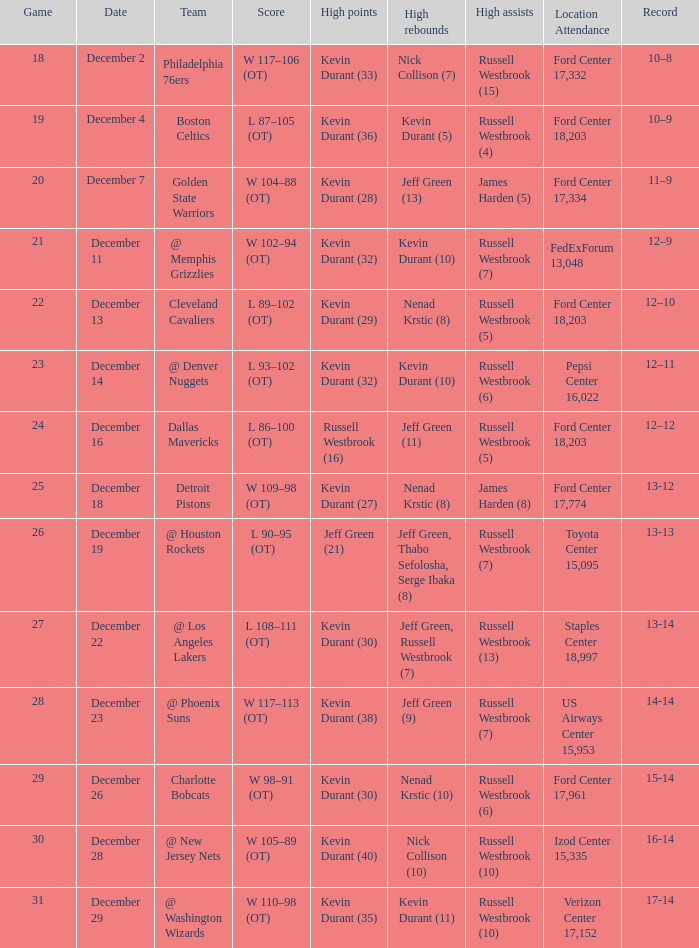What is the tally for the date of december 7? W 104–88 (OT). 